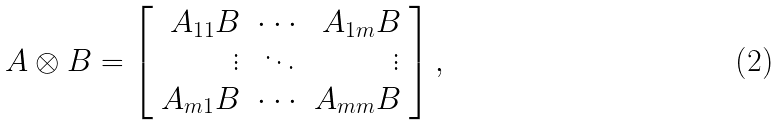Convert formula to latex. <formula><loc_0><loc_0><loc_500><loc_500>A \otimes B = \left [ \begin{array} { r r r } A _ { 1 1 } B & \cdot \cdot \cdot & A _ { 1 m } B \\ \vdots & \ddots & \vdots \\ A _ { m 1 } B & \cdot \cdot \cdot & A _ { m m } B \end{array} \right ] ,</formula> 